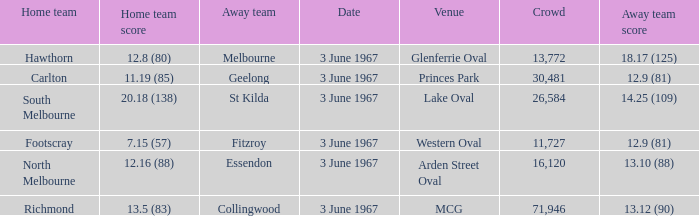Where did Geelong play as the away team? Princes Park. Could you parse the entire table as a dict? {'header': ['Home team', 'Home team score', 'Away team', 'Date', 'Venue', 'Crowd', 'Away team score'], 'rows': [['Hawthorn', '12.8 (80)', 'Melbourne', '3 June 1967', 'Glenferrie Oval', '13,772', '18.17 (125)'], ['Carlton', '11.19 (85)', 'Geelong', '3 June 1967', 'Princes Park', '30,481', '12.9 (81)'], ['South Melbourne', '20.18 (138)', 'St Kilda', '3 June 1967', 'Lake Oval', '26,584', '14.25 (109)'], ['Footscray', '7.15 (57)', 'Fitzroy', '3 June 1967', 'Western Oval', '11,727', '12.9 (81)'], ['North Melbourne', '12.16 (88)', 'Essendon', '3 June 1967', 'Arden Street Oval', '16,120', '13.10 (88)'], ['Richmond', '13.5 (83)', 'Collingwood', '3 June 1967', 'MCG', '71,946', '13.12 (90)']]} 